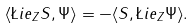Convert formula to latex. <formula><loc_0><loc_0><loc_500><loc_500>\langle \L i e _ { Z } S , \Psi \rangle = - \langle S , \L i e _ { Z } \Psi \rangle .</formula> 